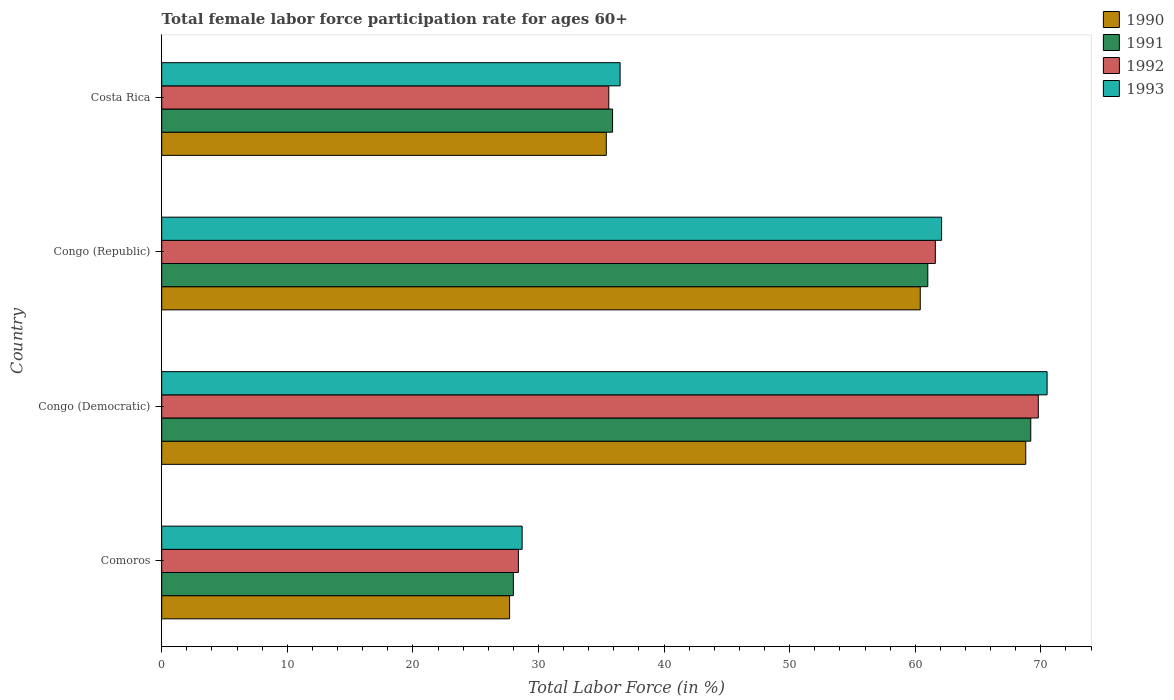How many different coloured bars are there?
Your answer should be compact. 4. How many bars are there on the 3rd tick from the bottom?
Provide a succinct answer. 4. What is the label of the 3rd group of bars from the top?
Offer a very short reply. Congo (Democratic). In how many cases, is the number of bars for a given country not equal to the number of legend labels?
Provide a short and direct response. 0. What is the female labor force participation rate in 1993 in Congo (Republic)?
Give a very brief answer. 62.1. Across all countries, what is the maximum female labor force participation rate in 1993?
Make the answer very short. 70.5. Across all countries, what is the minimum female labor force participation rate in 1993?
Make the answer very short. 28.7. In which country was the female labor force participation rate in 1991 maximum?
Give a very brief answer. Congo (Democratic). In which country was the female labor force participation rate in 1993 minimum?
Keep it short and to the point. Comoros. What is the total female labor force participation rate in 1990 in the graph?
Keep it short and to the point. 192.3. What is the difference between the female labor force participation rate in 1993 in Comoros and that in Costa Rica?
Your answer should be compact. -7.8. What is the difference between the female labor force participation rate in 1993 in Congo (Democratic) and the female labor force participation rate in 1992 in Costa Rica?
Make the answer very short. 34.9. What is the average female labor force participation rate in 1990 per country?
Your answer should be very brief. 48.08. What is the difference between the female labor force participation rate in 1990 and female labor force participation rate in 1991 in Congo (Democratic)?
Give a very brief answer. -0.4. What is the ratio of the female labor force participation rate in 1992 in Comoros to that in Congo (Democratic)?
Keep it short and to the point. 0.41. Is the female labor force participation rate in 1993 in Congo (Democratic) less than that in Costa Rica?
Offer a terse response. No. Is the difference between the female labor force participation rate in 1990 in Congo (Democratic) and Costa Rica greater than the difference between the female labor force participation rate in 1991 in Congo (Democratic) and Costa Rica?
Make the answer very short. Yes. What is the difference between the highest and the second highest female labor force participation rate in 1993?
Keep it short and to the point. 8.4. What is the difference between the highest and the lowest female labor force participation rate in 1991?
Give a very brief answer. 41.2. In how many countries, is the female labor force participation rate in 1991 greater than the average female labor force participation rate in 1991 taken over all countries?
Provide a succinct answer. 2. Is the sum of the female labor force participation rate in 1990 in Congo (Republic) and Costa Rica greater than the maximum female labor force participation rate in 1993 across all countries?
Offer a very short reply. Yes. What does the 1st bar from the top in Comoros represents?
Offer a terse response. 1993. What does the 2nd bar from the bottom in Congo (Republic) represents?
Give a very brief answer. 1991. Is it the case that in every country, the sum of the female labor force participation rate in 1990 and female labor force participation rate in 1991 is greater than the female labor force participation rate in 1993?
Provide a succinct answer. Yes. How many countries are there in the graph?
Your answer should be very brief. 4. How are the legend labels stacked?
Your answer should be compact. Vertical. What is the title of the graph?
Keep it short and to the point. Total female labor force participation rate for ages 60+. Does "1964" appear as one of the legend labels in the graph?
Ensure brevity in your answer.  No. What is the label or title of the X-axis?
Your answer should be compact. Total Labor Force (in %). What is the Total Labor Force (in %) in 1990 in Comoros?
Your answer should be very brief. 27.7. What is the Total Labor Force (in %) in 1991 in Comoros?
Offer a very short reply. 28. What is the Total Labor Force (in %) in 1992 in Comoros?
Your response must be concise. 28.4. What is the Total Labor Force (in %) in 1993 in Comoros?
Provide a short and direct response. 28.7. What is the Total Labor Force (in %) in 1990 in Congo (Democratic)?
Your answer should be compact. 68.8. What is the Total Labor Force (in %) of 1991 in Congo (Democratic)?
Your answer should be very brief. 69.2. What is the Total Labor Force (in %) in 1992 in Congo (Democratic)?
Ensure brevity in your answer.  69.8. What is the Total Labor Force (in %) in 1993 in Congo (Democratic)?
Ensure brevity in your answer.  70.5. What is the Total Labor Force (in %) in 1990 in Congo (Republic)?
Make the answer very short. 60.4. What is the Total Labor Force (in %) of 1991 in Congo (Republic)?
Give a very brief answer. 61. What is the Total Labor Force (in %) of 1992 in Congo (Republic)?
Ensure brevity in your answer.  61.6. What is the Total Labor Force (in %) in 1993 in Congo (Republic)?
Offer a terse response. 62.1. What is the Total Labor Force (in %) of 1990 in Costa Rica?
Ensure brevity in your answer.  35.4. What is the Total Labor Force (in %) in 1991 in Costa Rica?
Ensure brevity in your answer.  35.9. What is the Total Labor Force (in %) of 1992 in Costa Rica?
Your response must be concise. 35.6. What is the Total Labor Force (in %) of 1993 in Costa Rica?
Make the answer very short. 36.5. Across all countries, what is the maximum Total Labor Force (in %) in 1990?
Ensure brevity in your answer.  68.8. Across all countries, what is the maximum Total Labor Force (in %) of 1991?
Keep it short and to the point. 69.2. Across all countries, what is the maximum Total Labor Force (in %) of 1992?
Ensure brevity in your answer.  69.8. Across all countries, what is the maximum Total Labor Force (in %) in 1993?
Keep it short and to the point. 70.5. Across all countries, what is the minimum Total Labor Force (in %) in 1990?
Provide a short and direct response. 27.7. Across all countries, what is the minimum Total Labor Force (in %) in 1991?
Make the answer very short. 28. Across all countries, what is the minimum Total Labor Force (in %) of 1992?
Ensure brevity in your answer.  28.4. Across all countries, what is the minimum Total Labor Force (in %) in 1993?
Offer a very short reply. 28.7. What is the total Total Labor Force (in %) in 1990 in the graph?
Your response must be concise. 192.3. What is the total Total Labor Force (in %) in 1991 in the graph?
Provide a succinct answer. 194.1. What is the total Total Labor Force (in %) of 1992 in the graph?
Provide a short and direct response. 195.4. What is the total Total Labor Force (in %) in 1993 in the graph?
Keep it short and to the point. 197.8. What is the difference between the Total Labor Force (in %) in 1990 in Comoros and that in Congo (Democratic)?
Offer a terse response. -41.1. What is the difference between the Total Labor Force (in %) in 1991 in Comoros and that in Congo (Democratic)?
Provide a succinct answer. -41.2. What is the difference between the Total Labor Force (in %) in 1992 in Comoros and that in Congo (Democratic)?
Your answer should be very brief. -41.4. What is the difference between the Total Labor Force (in %) of 1993 in Comoros and that in Congo (Democratic)?
Offer a very short reply. -41.8. What is the difference between the Total Labor Force (in %) of 1990 in Comoros and that in Congo (Republic)?
Make the answer very short. -32.7. What is the difference between the Total Labor Force (in %) in 1991 in Comoros and that in Congo (Republic)?
Ensure brevity in your answer.  -33. What is the difference between the Total Labor Force (in %) of 1992 in Comoros and that in Congo (Republic)?
Give a very brief answer. -33.2. What is the difference between the Total Labor Force (in %) of 1993 in Comoros and that in Congo (Republic)?
Make the answer very short. -33.4. What is the difference between the Total Labor Force (in %) in 1990 in Comoros and that in Costa Rica?
Provide a short and direct response. -7.7. What is the difference between the Total Labor Force (in %) of 1991 in Comoros and that in Costa Rica?
Give a very brief answer. -7.9. What is the difference between the Total Labor Force (in %) of 1990 in Congo (Democratic) and that in Congo (Republic)?
Your answer should be compact. 8.4. What is the difference between the Total Labor Force (in %) in 1992 in Congo (Democratic) and that in Congo (Republic)?
Offer a very short reply. 8.2. What is the difference between the Total Labor Force (in %) of 1990 in Congo (Democratic) and that in Costa Rica?
Keep it short and to the point. 33.4. What is the difference between the Total Labor Force (in %) in 1991 in Congo (Democratic) and that in Costa Rica?
Make the answer very short. 33.3. What is the difference between the Total Labor Force (in %) in 1992 in Congo (Democratic) and that in Costa Rica?
Ensure brevity in your answer.  34.2. What is the difference between the Total Labor Force (in %) in 1993 in Congo (Democratic) and that in Costa Rica?
Your response must be concise. 34. What is the difference between the Total Labor Force (in %) of 1990 in Congo (Republic) and that in Costa Rica?
Keep it short and to the point. 25. What is the difference between the Total Labor Force (in %) in 1991 in Congo (Republic) and that in Costa Rica?
Provide a short and direct response. 25.1. What is the difference between the Total Labor Force (in %) in 1992 in Congo (Republic) and that in Costa Rica?
Ensure brevity in your answer.  26. What is the difference between the Total Labor Force (in %) of 1993 in Congo (Republic) and that in Costa Rica?
Make the answer very short. 25.6. What is the difference between the Total Labor Force (in %) in 1990 in Comoros and the Total Labor Force (in %) in 1991 in Congo (Democratic)?
Provide a succinct answer. -41.5. What is the difference between the Total Labor Force (in %) in 1990 in Comoros and the Total Labor Force (in %) in 1992 in Congo (Democratic)?
Offer a very short reply. -42.1. What is the difference between the Total Labor Force (in %) in 1990 in Comoros and the Total Labor Force (in %) in 1993 in Congo (Democratic)?
Keep it short and to the point. -42.8. What is the difference between the Total Labor Force (in %) in 1991 in Comoros and the Total Labor Force (in %) in 1992 in Congo (Democratic)?
Provide a succinct answer. -41.8. What is the difference between the Total Labor Force (in %) of 1991 in Comoros and the Total Labor Force (in %) of 1993 in Congo (Democratic)?
Provide a succinct answer. -42.5. What is the difference between the Total Labor Force (in %) of 1992 in Comoros and the Total Labor Force (in %) of 1993 in Congo (Democratic)?
Keep it short and to the point. -42.1. What is the difference between the Total Labor Force (in %) in 1990 in Comoros and the Total Labor Force (in %) in 1991 in Congo (Republic)?
Provide a short and direct response. -33.3. What is the difference between the Total Labor Force (in %) of 1990 in Comoros and the Total Labor Force (in %) of 1992 in Congo (Republic)?
Give a very brief answer. -33.9. What is the difference between the Total Labor Force (in %) of 1990 in Comoros and the Total Labor Force (in %) of 1993 in Congo (Republic)?
Keep it short and to the point. -34.4. What is the difference between the Total Labor Force (in %) of 1991 in Comoros and the Total Labor Force (in %) of 1992 in Congo (Republic)?
Give a very brief answer. -33.6. What is the difference between the Total Labor Force (in %) of 1991 in Comoros and the Total Labor Force (in %) of 1993 in Congo (Republic)?
Give a very brief answer. -34.1. What is the difference between the Total Labor Force (in %) of 1992 in Comoros and the Total Labor Force (in %) of 1993 in Congo (Republic)?
Offer a very short reply. -33.7. What is the difference between the Total Labor Force (in %) of 1990 in Comoros and the Total Labor Force (in %) of 1991 in Costa Rica?
Ensure brevity in your answer.  -8.2. What is the difference between the Total Labor Force (in %) in 1990 in Comoros and the Total Labor Force (in %) in 1993 in Costa Rica?
Give a very brief answer. -8.8. What is the difference between the Total Labor Force (in %) of 1991 in Comoros and the Total Labor Force (in %) of 1992 in Costa Rica?
Make the answer very short. -7.6. What is the difference between the Total Labor Force (in %) of 1992 in Comoros and the Total Labor Force (in %) of 1993 in Costa Rica?
Provide a succinct answer. -8.1. What is the difference between the Total Labor Force (in %) of 1990 in Congo (Democratic) and the Total Labor Force (in %) of 1992 in Congo (Republic)?
Provide a short and direct response. 7.2. What is the difference between the Total Labor Force (in %) in 1990 in Congo (Democratic) and the Total Labor Force (in %) in 1993 in Congo (Republic)?
Offer a very short reply. 6.7. What is the difference between the Total Labor Force (in %) of 1991 in Congo (Democratic) and the Total Labor Force (in %) of 1993 in Congo (Republic)?
Offer a very short reply. 7.1. What is the difference between the Total Labor Force (in %) in 1992 in Congo (Democratic) and the Total Labor Force (in %) in 1993 in Congo (Republic)?
Provide a succinct answer. 7.7. What is the difference between the Total Labor Force (in %) in 1990 in Congo (Democratic) and the Total Labor Force (in %) in 1991 in Costa Rica?
Offer a terse response. 32.9. What is the difference between the Total Labor Force (in %) of 1990 in Congo (Democratic) and the Total Labor Force (in %) of 1992 in Costa Rica?
Keep it short and to the point. 33.2. What is the difference between the Total Labor Force (in %) in 1990 in Congo (Democratic) and the Total Labor Force (in %) in 1993 in Costa Rica?
Keep it short and to the point. 32.3. What is the difference between the Total Labor Force (in %) of 1991 in Congo (Democratic) and the Total Labor Force (in %) of 1992 in Costa Rica?
Offer a very short reply. 33.6. What is the difference between the Total Labor Force (in %) in 1991 in Congo (Democratic) and the Total Labor Force (in %) in 1993 in Costa Rica?
Your answer should be very brief. 32.7. What is the difference between the Total Labor Force (in %) in 1992 in Congo (Democratic) and the Total Labor Force (in %) in 1993 in Costa Rica?
Ensure brevity in your answer.  33.3. What is the difference between the Total Labor Force (in %) of 1990 in Congo (Republic) and the Total Labor Force (in %) of 1991 in Costa Rica?
Offer a very short reply. 24.5. What is the difference between the Total Labor Force (in %) in 1990 in Congo (Republic) and the Total Labor Force (in %) in 1992 in Costa Rica?
Make the answer very short. 24.8. What is the difference between the Total Labor Force (in %) of 1990 in Congo (Republic) and the Total Labor Force (in %) of 1993 in Costa Rica?
Your answer should be very brief. 23.9. What is the difference between the Total Labor Force (in %) of 1991 in Congo (Republic) and the Total Labor Force (in %) of 1992 in Costa Rica?
Keep it short and to the point. 25.4. What is the difference between the Total Labor Force (in %) of 1992 in Congo (Republic) and the Total Labor Force (in %) of 1993 in Costa Rica?
Provide a short and direct response. 25.1. What is the average Total Labor Force (in %) in 1990 per country?
Your answer should be very brief. 48.08. What is the average Total Labor Force (in %) in 1991 per country?
Your response must be concise. 48.52. What is the average Total Labor Force (in %) in 1992 per country?
Make the answer very short. 48.85. What is the average Total Labor Force (in %) in 1993 per country?
Offer a terse response. 49.45. What is the difference between the Total Labor Force (in %) of 1990 and Total Labor Force (in %) of 1991 in Comoros?
Ensure brevity in your answer.  -0.3. What is the difference between the Total Labor Force (in %) of 1990 and Total Labor Force (in %) of 1992 in Comoros?
Make the answer very short. -0.7. What is the difference between the Total Labor Force (in %) of 1990 and Total Labor Force (in %) of 1993 in Comoros?
Provide a succinct answer. -1. What is the difference between the Total Labor Force (in %) in 1991 and Total Labor Force (in %) in 1993 in Comoros?
Provide a succinct answer. -0.7. What is the difference between the Total Labor Force (in %) in 1990 and Total Labor Force (in %) in 1991 in Congo (Democratic)?
Keep it short and to the point. -0.4. What is the difference between the Total Labor Force (in %) of 1990 and Total Labor Force (in %) of 1992 in Congo (Democratic)?
Offer a very short reply. -1. What is the difference between the Total Labor Force (in %) in 1991 and Total Labor Force (in %) in 1993 in Congo (Democratic)?
Provide a succinct answer. -1.3. What is the difference between the Total Labor Force (in %) of 1990 and Total Labor Force (in %) of 1991 in Congo (Republic)?
Make the answer very short. -0.6. What is the difference between the Total Labor Force (in %) in 1990 and Total Labor Force (in %) in 1992 in Congo (Republic)?
Keep it short and to the point. -1.2. What is the difference between the Total Labor Force (in %) in 1990 and Total Labor Force (in %) in 1993 in Congo (Republic)?
Give a very brief answer. -1.7. What is the difference between the Total Labor Force (in %) in 1991 and Total Labor Force (in %) in 1993 in Congo (Republic)?
Provide a short and direct response. -1.1. What is the difference between the Total Labor Force (in %) in 1990 and Total Labor Force (in %) in 1992 in Costa Rica?
Ensure brevity in your answer.  -0.2. What is the difference between the Total Labor Force (in %) in 1990 and Total Labor Force (in %) in 1993 in Costa Rica?
Ensure brevity in your answer.  -1.1. What is the ratio of the Total Labor Force (in %) of 1990 in Comoros to that in Congo (Democratic)?
Offer a very short reply. 0.4. What is the ratio of the Total Labor Force (in %) of 1991 in Comoros to that in Congo (Democratic)?
Keep it short and to the point. 0.4. What is the ratio of the Total Labor Force (in %) of 1992 in Comoros to that in Congo (Democratic)?
Make the answer very short. 0.41. What is the ratio of the Total Labor Force (in %) of 1993 in Comoros to that in Congo (Democratic)?
Provide a short and direct response. 0.41. What is the ratio of the Total Labor Force (in %) in 1990 in Comoros to that in Congo (Republic)?
Provide a succinct answer. 0.46. What is the ratio of the Total Labor Force (in %) in 1991 in Comoros to that in Congo (Republic)?
Offer a very short reply. 0.46. What is the ratio of the Total Labor Force (in %) of 1992 in Comoros to that in Congo (Republic)?
Offer a very short reply. 0.46. What is the ratio of the Total Labor Force (in %) of 1993 in Comoros to that in Congo (Republic)?
Ensure brevity in your answer.  0.46. What is the ratio of the Total Labor Force (in %) in 1990 in Comoros to that in Costa Rica?
Provide a short and direct response. 0.78. What is the ratio of the Total Labor Force (in %) of 1991 in Comoros to that in Costa Rica?
Give a very brief answer. 0.78. What is the ratio of the Total Labor Force (in %) in 1992 in Comoros to that in Costa Rica?
Offer a very short reply. 0.8. What is the ratio of the Total Labor Force (in %) in 1993 in Comoros to that in Costa Rica?
Ensure brevity in your answer.  0.79. What is the ratio of the Total Labor Force (in %) of 1990 in Congo (Democratic) to that in Congo (Republic)?
Offer a very short reply. 1.14. What is the ratio of the Total Labor Force (in %) of 1991 in Congo (Democratic) to that in Congo (Republic)?
Offer a terse response. 1.13. What is the ratio of the Total Labor Force (in %) of 1992 in Congo (Democratic) to that in Congo (Republic)?
Make the answer very short. 1.13. What is the ratio of the Total Labor Force (in %) of 1993 in Congo (Democratic) to that in Congo (Republic)?
Your response must be concise. 1.14. What is the ratio of the Total Labor Force (in %) of 1990 in Congo (Democratic) to that in Costa Rica?
Offer a terse response. 1.94. What is the ratio of the Total Labor Force (in %) in 1991 in Congo (Democratic) to that in Costa Rica?
Ensure brevity in your answer.  1.93. What is the ratio of the Total Labor Force (in %) in 1992 in Congo (Democratic) to that in Costa Rica?
Your answer should be compact. 1.96. What is the ratio of the Total Labor Force (in %) in 1993 in Congo (Democratic) to that in Costa Rica?
Give a very brief answer. 1.93. What is the ratio of the Total Labor Force (in %) in 1990 in Congo (Republic) to that in Costa Rica?
Your answer should be very brief. 1.71. What is the ratio of the Total Labor Force (in %) in 1991 in Congo (Republic) to that in Costa Rica?
Make the answer very short. 1.7. What is the ratio of the Total Labor Force (in %) in 1992 in Congo (Republic) to that in Costa Rica?
Keep it short and to the point. 1.73. What is the ratio of the Total Labor Force (in %) of 1993 in Congo (Republic) to that in Costa Rica?
Your response must be concise. 1.7. What is the difference between the highest and the second highest Total Labor Force (in %) of 1990?
Offer a very short reply. 8.4. What is the difference between the highest and the second highest Total Labor Force (in %) in 1993?
Offer a very short reply. 8.4. What is the difference between the highest and the lowest Total Labor Force (in %) of 1990?
Provide a succinct answer. 41.1. What is the difference between the highest and the lowest Total Labor Force (in %) in 1991?
Ensure brevity in your answer.  41.2. What is the difference between the highest and the lowest Total Labor Force (in %) of 1992?
Offer a very short reply. 41.4. What is the difference between the highest and the lowest Total Labor Force (in %) in 1993?
Keep it short and to the point. 41.8. 